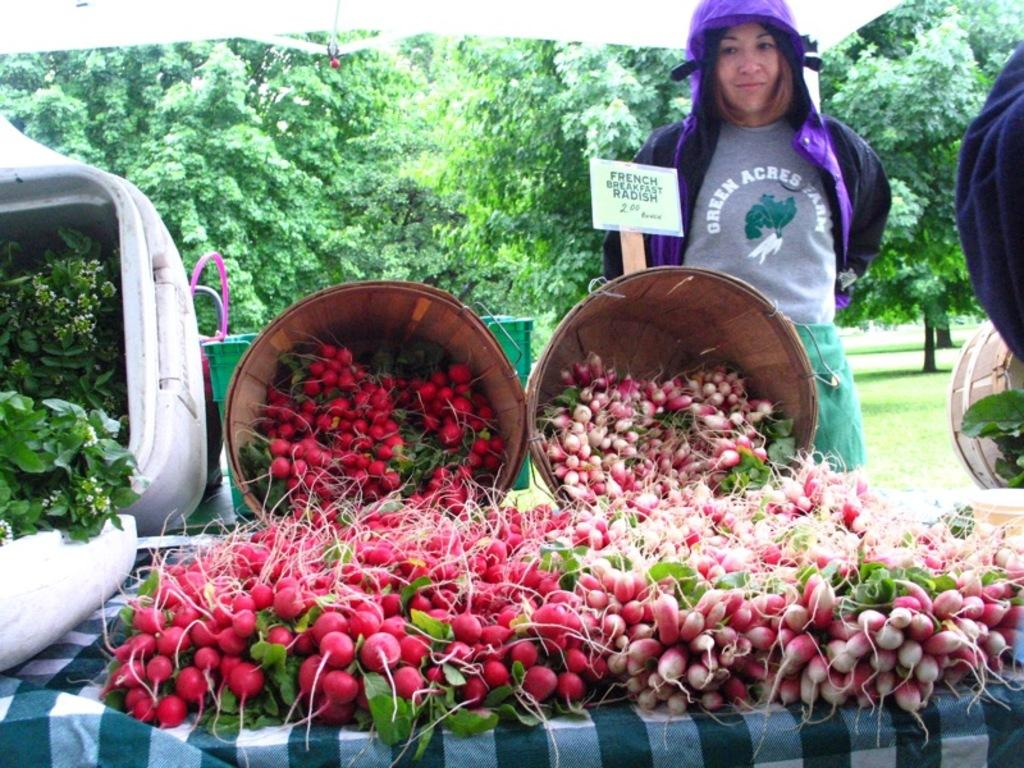What type of vegetables are in the foreground of the image? There are radishes in the foreground of the image. What is the woman in the image doing? The woman is standing behind a basket in the image. What can be seen in the background of the image? There are trees in the background of the image. What type of orange is the woman holding in the image? There is no orange present in the image; the woman is standing behind a basket, and the main subject in the foreground is radishes. 